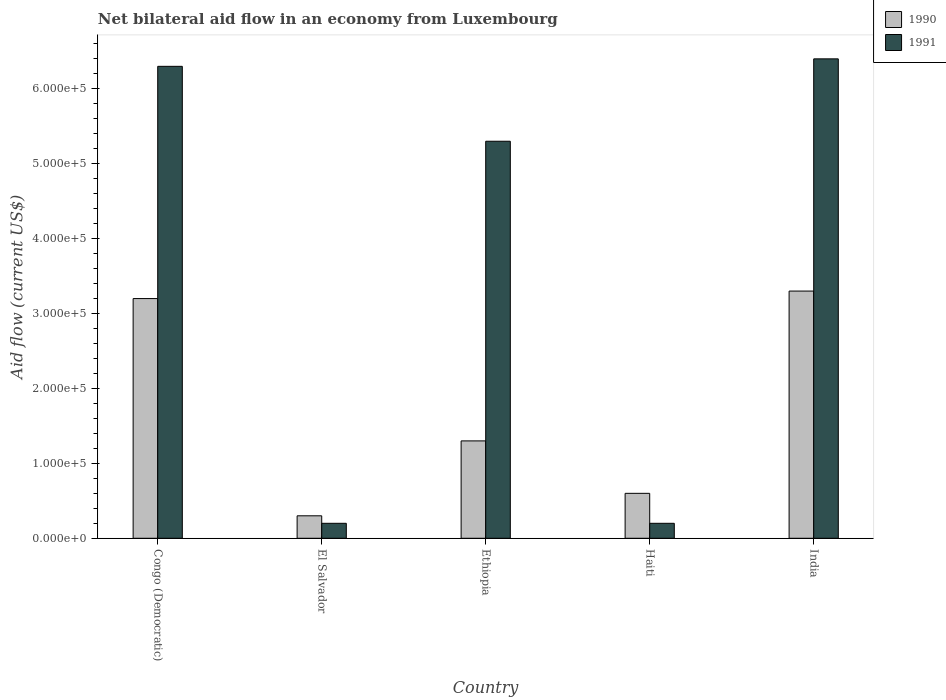What is the label of the 1st group of bars from the left?
Ensure brevity in your answer.  Congo (Democratic). In how many cases, is the number of bars for a given country not equal to the number of legend labels?
Provide a short and direct response. 0. What is the net bilateral aid flow in 1991 in Haiti?
Offer a terse response. 2.00e+04. Across all countries, what is the maximum net bilateral aid flow in 1991?
Offer a terse response. 6.40e+05. Across all countries, what is the minimum net bilateral aid flow in 1991?
Make the answer very short. 2.00e+04. In which country was the net bilateral aid flow in 1990 minimum?
Ensure brevity in your answer.  El Salvador. What is the total net bilateral aid flow in 1991 in the graph?
Offer a very short reply. 1.84e+06. What is the difference between the net bilateral aid flow in 1991 in El Salvador and that in Ethiopia?
Your answer should be compact. -5.10e+05. What is the difference between the net bilateral aid flow in 1991 in India and the net bilateral aid flow in 1990 in Haiti?
Give a very brief answer. 5.80e+05. What is the average net bilateral aid flow in 1990 per country?
Your answer should be very brief. 1.74e+05. What is the difference between the net bilateral aid flow of/in 1991 and net bilateral aid flow of/in 1990 in Congo (Democratic)?
Give a very brief answer. 3.10e+05. In how many countries, is the net bilateral aid flow in 1990 greater than 360000 US$?
Keep it short and to the point. 0. What is the ratio of the net bilateral aid flow in 1991 in El Salvador to that in Ethiopia?
Offer a terse response. 0.04. Is the net bilateral aid flow in 1990 in Congo (Democratic) less than that in Haiti?
Offer a very short reply. No. Is the difference between the net bilateral aid flow in 1991 in Ethiopia and India greater than the difference between the net bilateral aid flow in 1990 in Ethiopia and India?
Ensure brevity in your answer.  Yes. What is the difference between the highest and the second highest net bilateral aid flow in 1990?
Your answer should be compact. 10000. What is the difference between the highest and the lowest net bilateral aid flow in 1991?
Give a very brief answer. 6.20e+05. What does the 2nd bar from the left in India represents?
Keep it short and to the point. 1991. How many bars are there?
Ensure brevity in your answer.  10. Are all the bars in the graph horizontal?
Keep it short and to the point. No. How many countries are there in the graph?
Make the answer very short. 5. Are the values on the major ticks of Y-axis written in scientific E-notation?
Make the answer very short. Yes. Does the graph contain grids?
Keep it short and to the point. No. How many legend labels are there?
Give a very brief answer. 2. What is the title of the graph?
Provide a succinct answer. Net bilateral aid flow in an economy from Luxembourg. Does "1969" appear as one of the legend labels in the graph?
Your answer should be compact. No. What is the Aid flow (current US$) in 1990 in Congo (Democratic)?
Offer a very short reply. 3.20e+05. What is the Aid flow (current US$) of 1991 in Congo (Democratic)?
Keep it short and to the point. 6.30e+05. What is the Aid flow (current US$) in 1990 in El Salvador?
Offer a very short reply. 3.00e+04. What is the Aid flow (current US$) in 1991 in Ethiopia?
Provide a short and direct response. 5.30e+05. What is the Aid flow (current US$) of 1991 in India?
Make the answer very short. 6.40e+05. Across all countries, what is the maximum Aid flow (current US$) of 1991?
Make the answer very short. 6.40e+05. Across all countries, what is the minimum Aid flow (current US$) of 1991?
Your response must be concise. 2.00e+04. What is the total Aid flow (current US$) in 1990 in the graph?
Make the answer very short. 8.70e+05. What is the total Aid flow (current US$) of 1991 in the graph?
Offer a very short reply. 1.84e+06. What is the difference between the Aid flow (current US$) in 1990 in Congo (Democratic) and that in Ethiopia?
Your answer should be very brief. 1.90e+05. What is the difference between the Aid flow (current US$) of 1991 in Congo (Democratic) and that in Ethiopia?
Offer a terse response. 1.00e+05. What is the difference between the Aid flow (current US$) in 1991 in Congo (Democratic) and that in Haiti?
Make the answer very short. 6.10e+05. What is the difference between the Aid flow (current US$) in 1990 in Congo (Democratic) and that in India?
Your answer should be compact. -10000. What is the difference between the Aid flow (current US$) of 1990 in El Salvador and that in Ethiopia?
Your answer should be compact. -1.00e+05. What is the difference between the Aid flow (current US$) in 1991 in El Salvador and that in Ethiopia?
Provide a succinct answer. -5.10e+05. What is the difference between the Aid flow (current US$) of 1990 in El Salvador and that in Haiti?
Offer a terse response. -3.00e+04. What is the difference between the Aid flow (current US$) in 1991 in El Salvador and that in Haiti?
Provide a short and direct response. 0. What is the difference between the Aid flow (current US$) in 1991 in El Salvador and that in India?
Your answer should be compact. -6.20e+05. What is the difference between the Aid flow (current US$) of 1990 in Ethiopia and that in Haiti?
Provide a succinct answer. 7.00e+04. What is the difference between the Aid flow (current US$) of 1991 in Ethiopia and that in Haiti?
Your answer should be compact. 5.10e+05. What is the difference between the Aid flow (current US$) of 1990 in Ethiopia and that in India?
Offer a very short reply. -2.00e+05. What is the difference between the Aid flow (current US$) in 1991 in Ethiopia and that in India?
Your answer should be compact. -1.10e+05. What is the difference between the Aid flow (current US$) of 1990 in Haiti and that in India?
Ensure brevity in your answer.  -2.70e+05. What is the difference between the Aid flow (current US$) of 1991 in Haiti and that in India?
Offer a very short reply. -6.20e+05. What is the difference between the Aid flow (current US$) in 1990 in Congo (Democratic) and the Aid flow (current US$) in 1991 in Ethiopia?
Offer a terse response. -2.10e+05. What is the difference between the Aid flow (current US$) of 1990 in Congo (Democratic) and the Aid flow (current US$) of 1991 in Haiti?
Provide a succinct answer. 3.00e+05. What is the difference between the Aid flow (current US$) in 1990 in Congo (Democratic) and the Aid flow (current US$) in 1991 in India?
Your answer should be very brief. -3.20e+05. What is the difference between the Aid flow (current US$) of 1990 in El Salvador and the Aid flow (current US$) of 1991 in Ethiopia?
Offer a very short reply. -5.00e+05. What is the difference between the Aid flow (current US$) of 1990 in El Salvador and the Aid flow (current US$) of 1991 in India?
Keep it short and to the point. -6.10e+05. What is the difference between the Aid flow (current US$) of 1990 in Ethiopia and the Aid flow (current US$) of 1991 in India?
Your response must be concise. -5.10e+05. What is the difference between the Aid flow (current US$) of 1990 in Haiti and the Aid flow (current US$) of 1991 in India?
Your answer should be very brief. -5.80e+05. What is the average Aid flow (current US$) in 1990 per country?
Offer a terse response. 1.74e+05. What is the average Aid flow (current US$) of 1991 per country?
Keep it short and to the point. 3.68e+05. What is the difference between the Aid flow (current US$) of 1990 and Aid flow (current US$) of 1991 in Congo (Democratic)?
Provide a short and direct response. -3.10e+05. What is the difference between the Aid flow (current US$) in 1990 and Aid flow (current US$) in 1991 in El Salvador?
Keep it short and to the point. 10000. What is the difference between the Aid flow (current US$) in 1990 and Aid flow (current US$) in 1991 in Ethiopia?
Provide a succinct answer. -4.00e+05. What is the difference between the Aid flow (current US$) of 1990 and Aid flow (current US$) of 1991 in India?
Provide a short and direct response. -3.10e+05. What is the ratio of the Aid flow (current US$) of 1990 in Congo (Democratic) to that in El Salvador?
Offer a terse response. 10.67. What is the ratio of the Aid flow (current US$) in 1991 in Congo (Democratic) to that in El Salvador?
Your answer should be compact. 31.5. What is the ratio of the Aid flow (current US$) of 1990 in Congo (Democratic) to that in Ethiopia?
Make the answer very short. 2.46. What is the ratio of the Aid flow (current US$) in 1991 in Congo (Democratic) to that in Ethiopia?
Provide a succinct answer. 1.19. What is the ratio of the Aid flow (current US$) in 1990 in Congo (Democratic) to that in Haiti?
Provide a short and direct response. 5.33. What is the ratio of the Aid flow (current US$) of 1991 in Congo (Democratic) to that in Haiti?
Give a very brief answer. 31.5. What is the ratio of the Aid flow (current US$) of 1990 in Congo (Democratic) to that in India?
Provide a short and direct response. 0.97. What is the ratio of the Aid flow (current US$) in 1991 in Congo (Democratic) to that in India?
Give a very brief answer. 0.98. What is the ratio of the Aid flow (current US$) of 1990 in El Salvador to that in Ethiopia?
Your answer should be compact. 0.23. What is the ratio of the Aid flow (current US$) of 1991 in El Salvador to that in Ethiopia?
Your answer should be very brief. 0.04. What is the ratio of the Aid flow (current US$) in 1990 in El Salvador to that in Haiti?
Give a very brief answer. 0.5. What is the ratio of the Aid flow (current US$) in 1991 in El Salvador to that in Haiti?
Give a very brief answer. 1. What is the ratio of the Aid flow (current US$) in 1990 in El Salvador to that in India?
Your answer should be very brief. 0.09. What is the ratio of the Aid flow (current US$) in 1991 in El Salvador to that in India?
Your answer should be compact. 0.03. What is the ratio of the Aid flow (current US$) in 1990 in Ethiopia to that in Haiti?
Your answer should be compact. 2.17. What is the ratio of the Aid flow (current US$) in 1991 in Ethiopia to that in Haiti?
Provide a succinct answer. 26.5. What is the ratio of the Aid flow (current US$) in 1990 in Ethiopia to that in India?
Ensure brevity in your answer.  0.39. What is the ratio of the Aid flow (current US$) of 1991 in Ethiopia to that in India?
Offer a terse response. 0.83. What is the ratio of the Aid flow (current US$) in 1990 in Haiti to that in India?
Make the answer very short. 0.18. What is the ratio of the Aid flow (current US$) of 1991 in Haiti to that in India?
Your answer should be very brief. 0.03. What is the difference between the highest and the lowest Aid flow (current US$) in 1990?
Provide a succinct answer. 3.00e+05. What is the difference between the highest and the lowest Aid flow (current US$) of 1991?
Your answer should be very brief. 6.20e+05. 